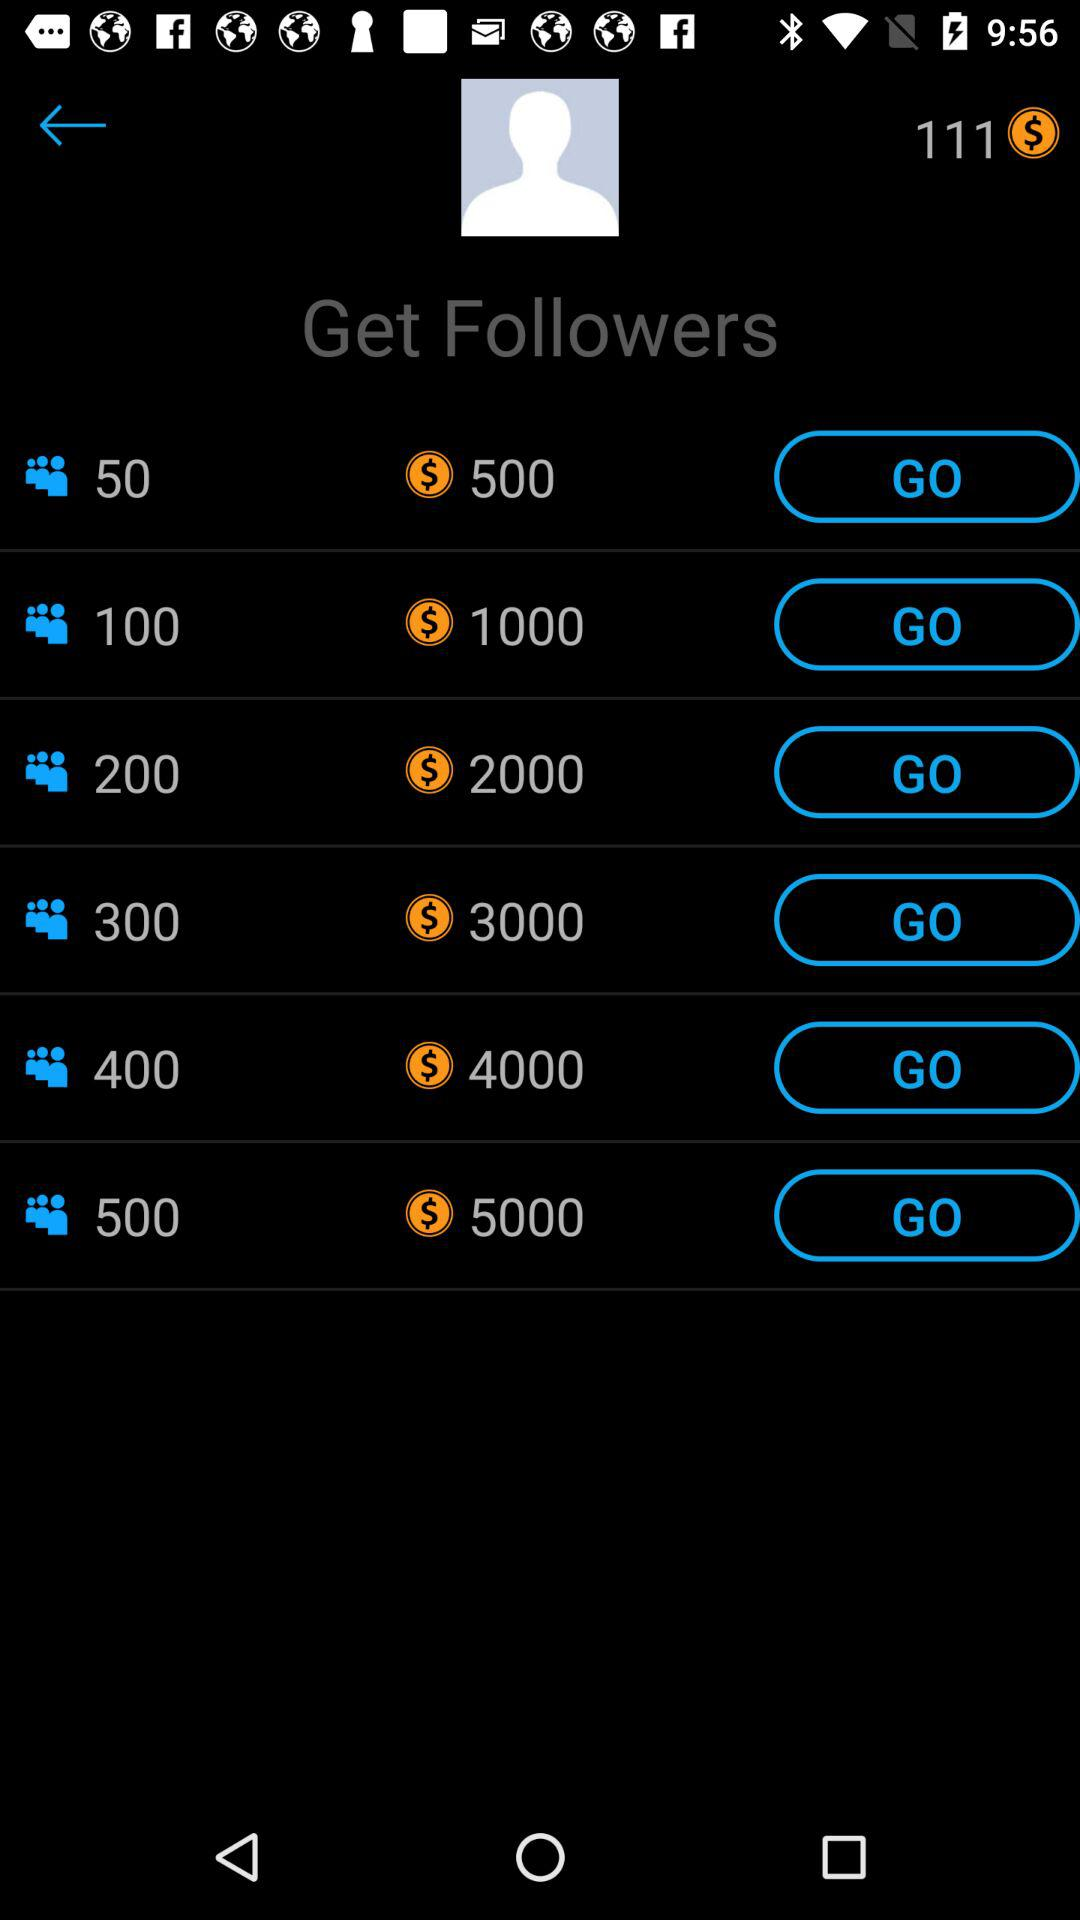How much will be paid for 500 followers? For 500 followers, $5000 will be paid. 